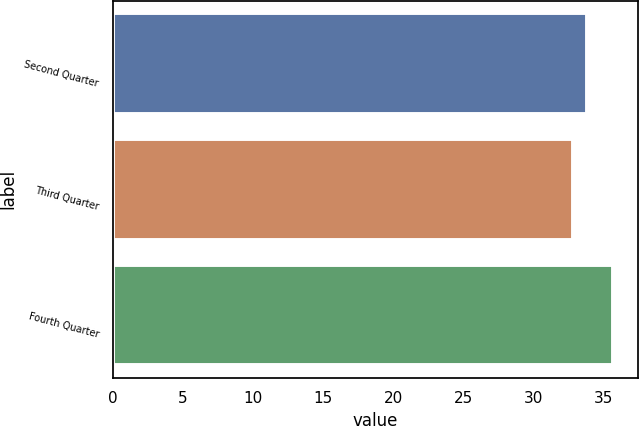Convert chart to OTSL. <chart><loc_0><loc_0><loc_500><loc_500><bar_chart><fcel>Second Quarter<fcel>Third Quarter<fcel>Fourth Quarter<nl><fcel>33.83<fcel>32.88<fcel>35.68<nl></chart> 